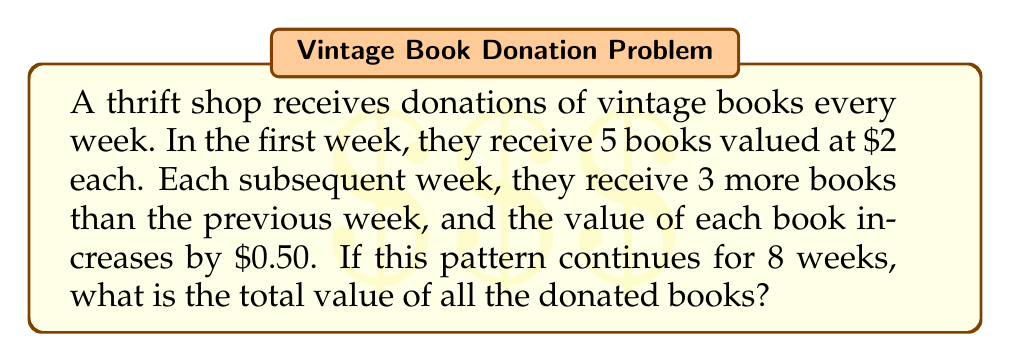Teach me how to tackle this problem. Let's approach this step-by-step using arithmetic sequences:

1) Number of books each week:
   - Week 1: 5 books
   - Week 2: 5 + 3 = 8 books
   - Week 3: 8 + 3 = 11 books
   This forms an arithmetic sequence with $a_1 = 5$ and $d = 3$
   General term: $a_n = a_1 + (n-1)d = 5 + 3(n-1) = 3n + 2$

2) Value of each book each week:
   - Week 1: $2.00
   - Week 2: $2.50
   - Week 3: $3.00
   This forms an arithmetic sequence with $a_1 = 2$ and $d = 0.50$
   General term: $b_n = a_1 + (n-1)d = 2 + 0.50(n-1) = 0.50n + 1.50$

3) Total value for each week:
   $V_n = (3n + 2)(0.50n + 1.50)$
   $V_n = 1.50n^2 + 4.50n + 3$

4) Sum of values for 8 weeks:
   $$S_8 = \sum_{n=1}^8 (1.50n^2 + 4.50n + 3)$$

5) Using the formulas for sum of squares and sum of natural numbers:
   $$\sum_{n=1}^n n^2 = \frac{n(n+1)(2n+1)}{6}$$
   $$\sum_{n=1}^n n = \frac{n(n+1)}{2}$$

6) Substituting n = 8:
   $$S_8 = 1.50 \cdot \frac{8 \cdot 9 \cdot 17}{6} + 4.50 \cdot \frac{8 \cdot 9}{2} + 3 \cdot 8$$
   $$S_8 = 306 + 162 + 24 = 492$$

Therefore, the total value of all donated books over 8 weeks is $492.
Answer: $492 